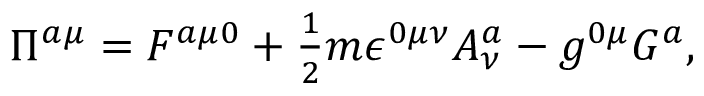Convert formula to latex. <formula><loc_0><loc_0><loc_500><loc_500>\Pi ^ { a \mu } = F ^ { a \mu 0 } + \frac { 1 } { 2 } m \epsilon ^ { 0 \mu \nu } A _ { \nu } ^ { a } - g ^ { 0 \mu } G ^ { a } ,</formula> 